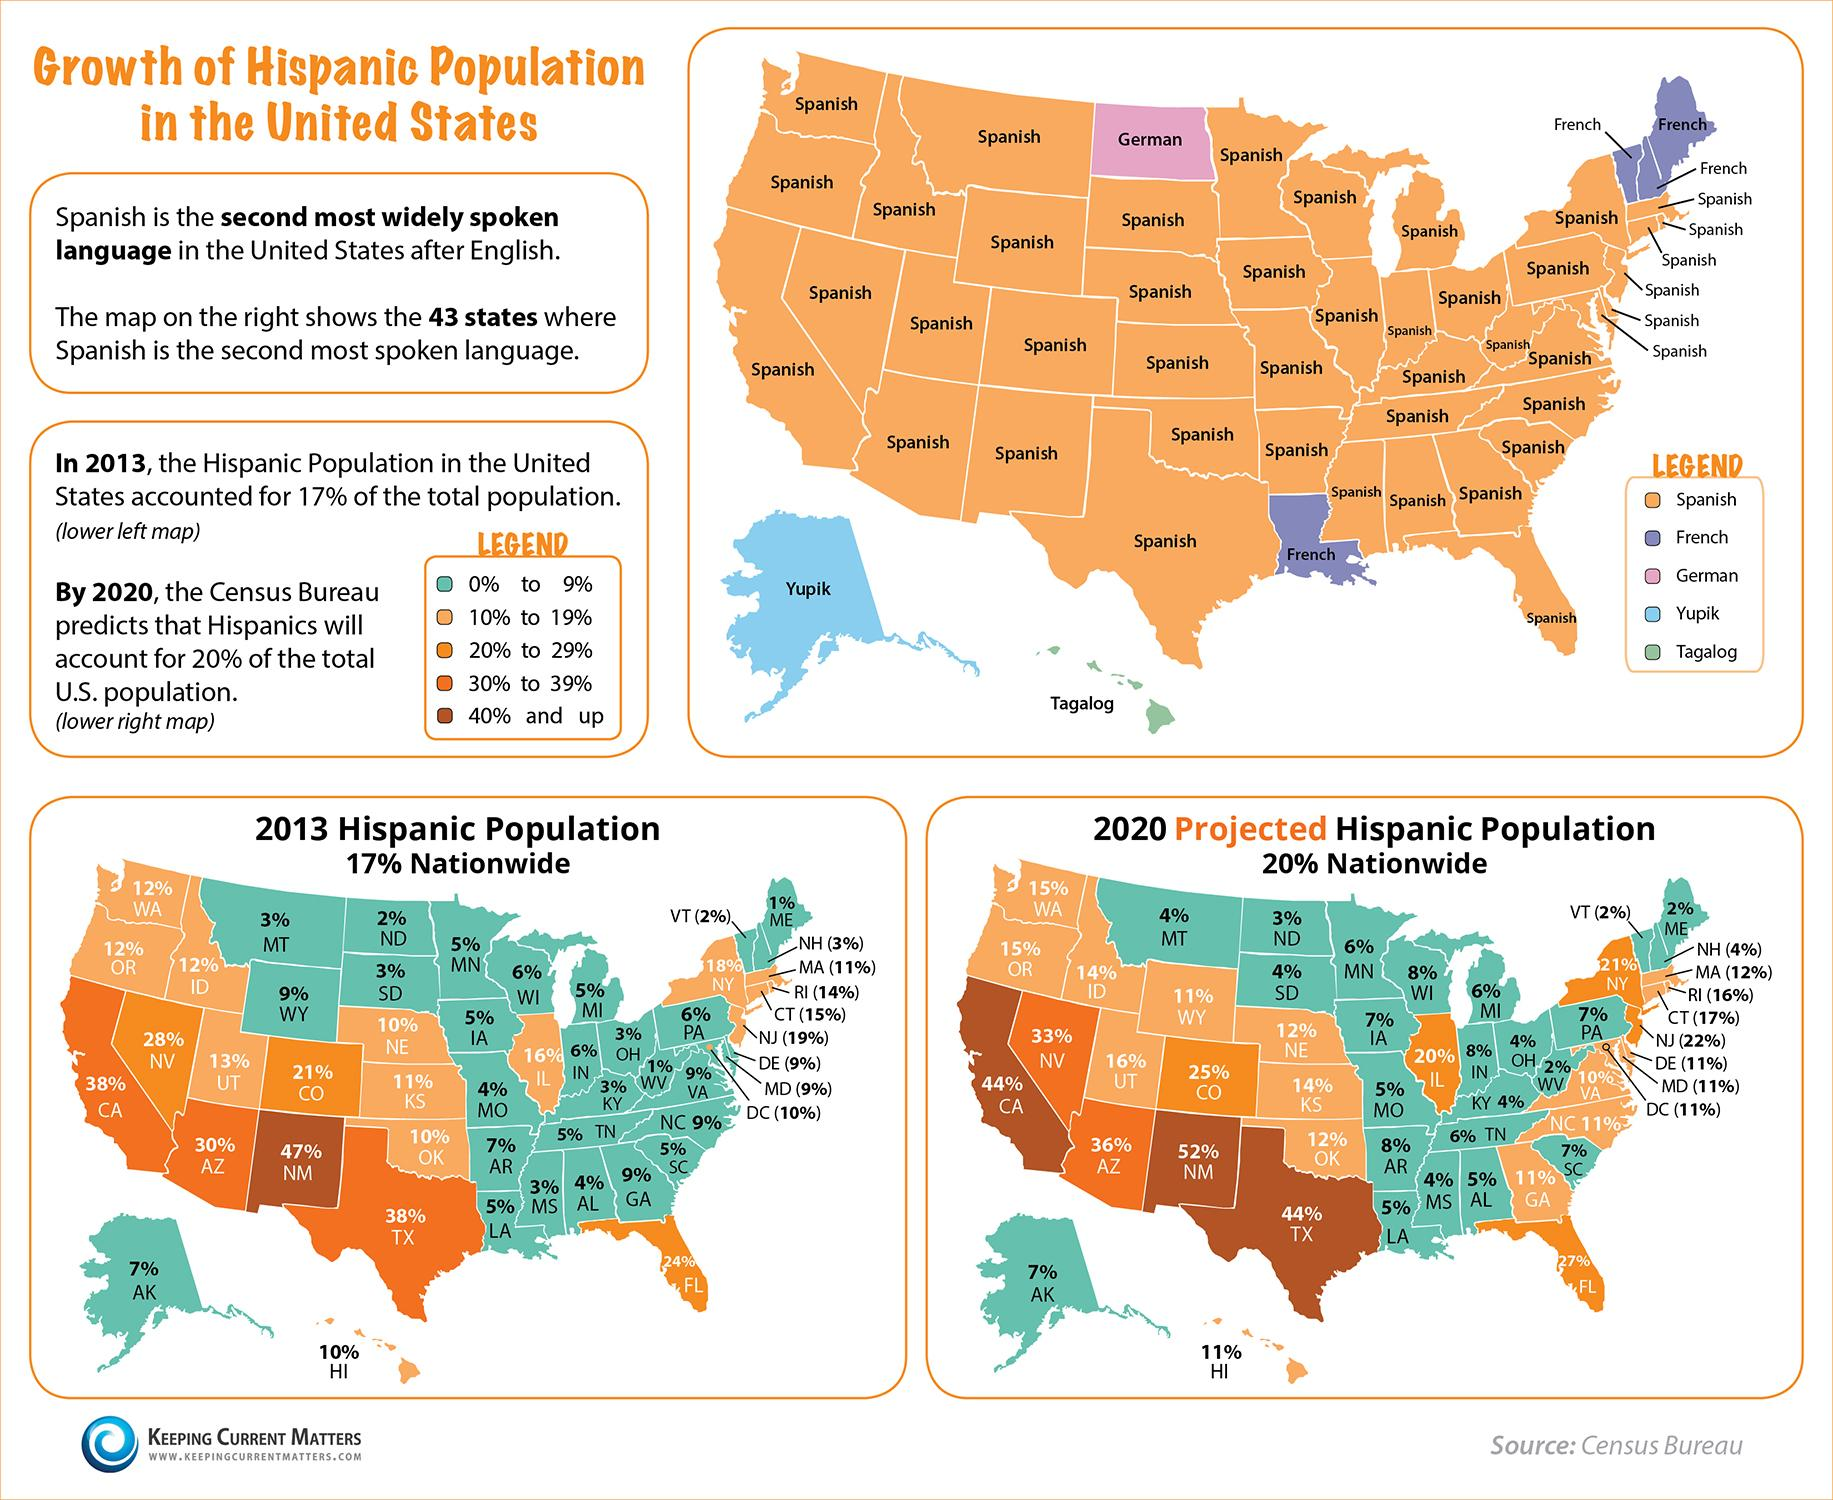Highlight a few significant elements in this photo. The Hispanic population in the state of Texas accounted for 38% of the total population in 2013. By 2020, it is projected that at least three states will have a Hispanic population that exceeds 40% of their total population. In 2013, three states had Hispanic populations that ranged from 20% to 29%. Yupik is the second most widely used language, besides English, in the state of Alaska. In how many states is French the second most widely used language? 